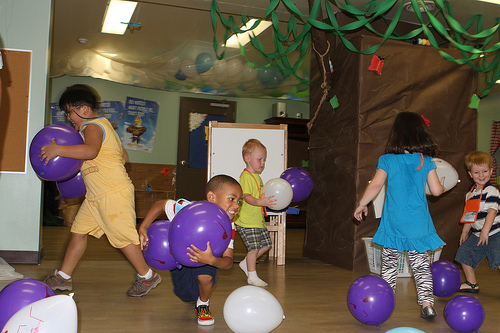<image>
Is there a balloon on the ground? Yes. Looking at the image, I can see the balloon is positioned on top of the ground, with the ground providing support. Is there a ballon in front of the boy? Yes. The ballon is positioned in front of the boy, appearing closer to the camera viewpoint. Where is the baloon in relation to the child? Is it in front of the child? No. The baloon is not in front of the child. The spatial positioning shows a different relationship between these objects. 